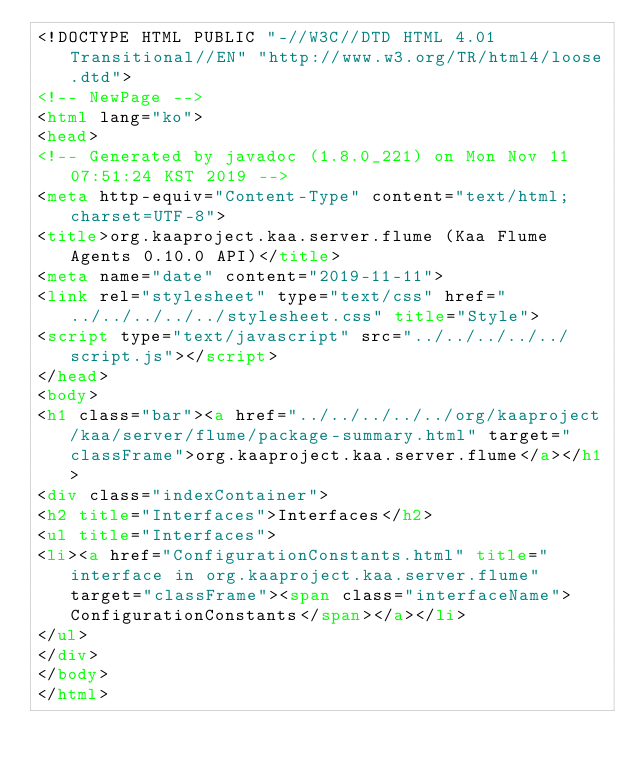Convert code to text. <code><loc_0><loc_0><loc_500><loc_500><_HTML_><!DOCTYPE HTML PUBLIC "-//W3C//DTD HTML 4.01 Transitional//EN" "http://www.w3.org/TR/html4/loose.dtd">
<!-- NewPage -->
<html lang="ko">
<head>
<!-- Generated by javadoc (1.8.0_221) on Mon Nov 11 07:51:24 KST 2019 -->
<meta http-equiv="Content-Type" content="text/html; charset=UTF-8">
<title>org.kaaproject.kaa.server.flume (Kaa Flume Agents 0.10.0 API)</title>
<meta name="date" content="2019-11-11">
<link rel="stylesheet" type="text/css" href="../../../../../stylesheet.css" title="Style">
<script type="text/javascript" src="../../../../../script.js"></script>
</head>
<body>
<h1 class="bar"><a href="../../../../../org/kaaproject/kaa/server/flume/package-summary.html" target="classFrame">org.kaaproject.kaa.server.flume</a></h1>
<div class="indexContainer">
<h2 title="Interfaces">Interfaces</h2>
<ul title="Interfaces">
<li><a href="ConfigurationConstants.html" title="interface in org.kaaproject.kaa.server.flume" target="classFrame"><span class="interfaceName">ConfigurationConstants</span></a></li>
</ul>
</div>
</body>
</html>
</code> 